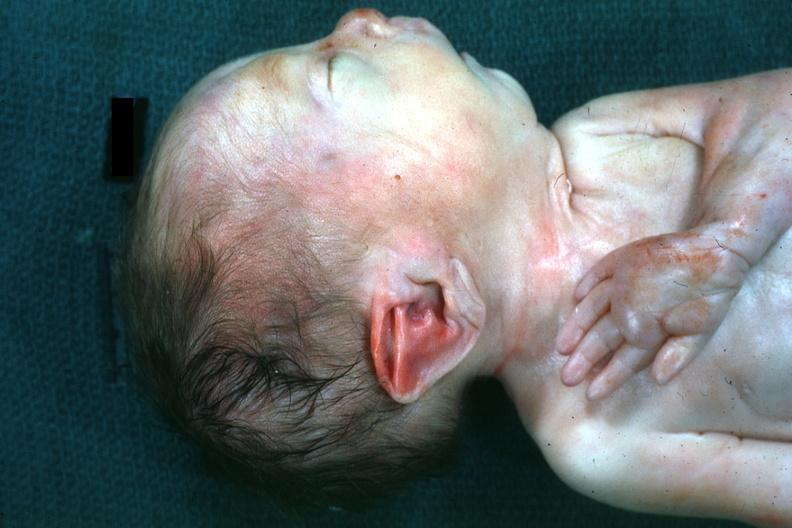s potters facies present?
Answer the question using a single word or phrase. Yes 